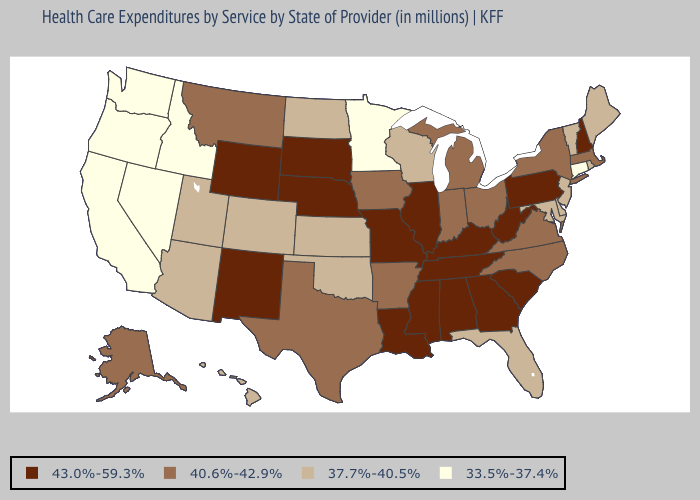What is the lowest value in the South?
Be succinct. 37.7%-40.5%. Does Michigan have a higher value than Colorado?
Quick response, please. Yes. What is the lowest value in the USA?
Concise answer only. 33.5%-37.4%. Name the states that have a value in the range 40.6%-42.9%?
Give a very brief answer. Alaska, Arkansas, Indiana, Iowa, Massachusetts, Michigan, Montana, New York, North Carolina, Ohio, Texas, Virginia. Name the states that have a value in the range 37.7%-40.5%?
Answer briefly. Arizona, Colorado, Delaware, Florida, Hawaii, Kansas, Maine, Maryland, New Jersey, North Dakota, Oklahoma, Rhode Island, Utah, Vermont, Wisconsin. What is the highest value in the West ?
Concise answer only. 43.0%-59.3%. Which states hav the highest value in the South?
Quick response, please. Alabama, Georgia, Kentucky, Louisiana, Mississippi, South Carolina, Tennessee, West Virginia. Which states have the highest value in the USA?
Keep it brief. Alabama, Georgia, Illinois, Kentucky, Louisiana, Mississippi, Missouri, Nebraska, New Hampshire, New Mexico, Pennsylvania, South Carolina, South Dakota, Tennessee, West Virginia, Wyoming. Is the legend a continuous bar?
Give a very brief answer. No. Does the map have missing data?
Write a very short answer. No. Which states have the highest value in the USA?
Concise answer only. Alabama, Georgia, Illinois, Kentucky, Louisiana, Mississippi, Missouri, Nebraska, New Hampshire, New Mexico, Pennsylvania, South Carolina, South Dakota, Tennessee, West Virginia, Wyoming. Does Rhode Island have the same value as Delaware?
Quick response, please. Yes. Name the states that have a value in the range 37.7%-40.5%?
Short answer required. Arizona, Colorado, Delaware, Florida, Hawaii, Kansas, Maine, Maryland, New Jersey, North Dakota, Oklahoma, Rhode Island, Utah, Vermont, Wisconsin. Does the first symbol in the legend represent the smallest category?
Quick response, please. No. What is the value of New Jersey?
Short answer required. 37.7%-40.5%. 